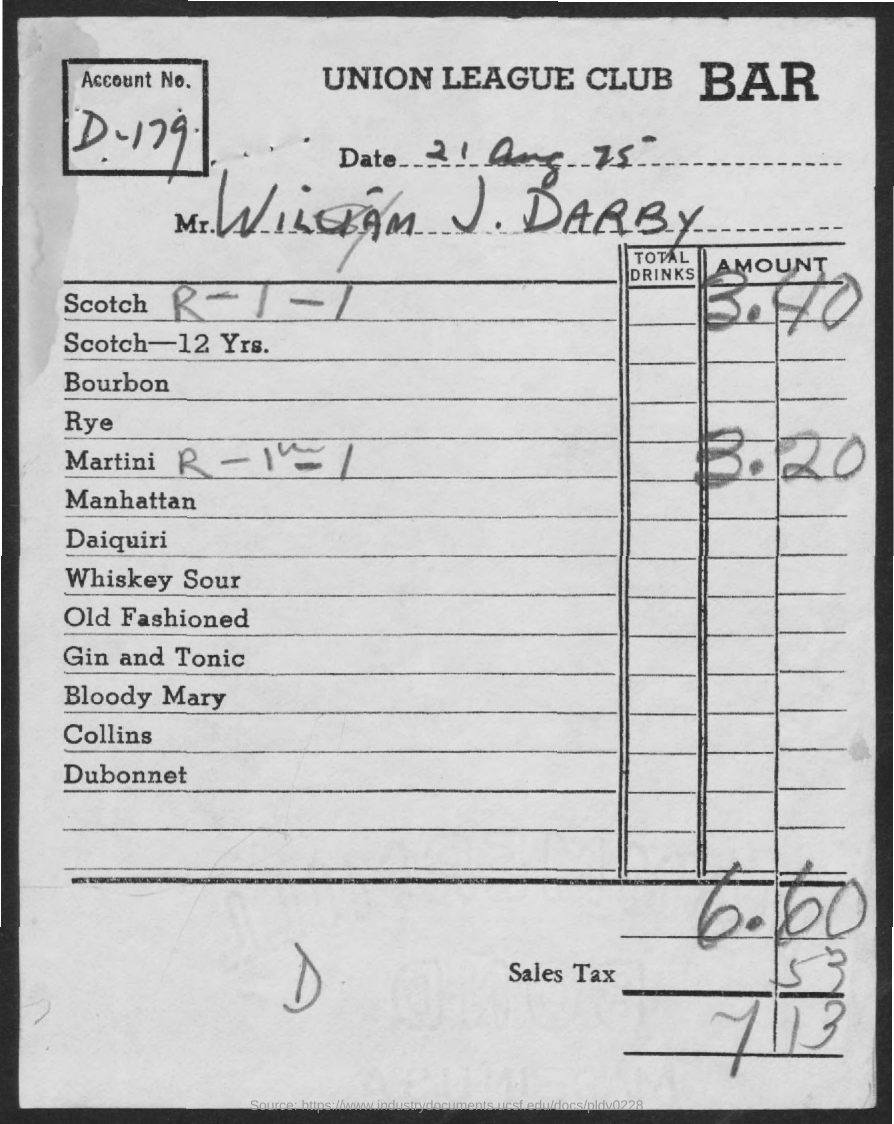Draw attention to some important aspects in this diagram. The amount for a Martini is 3.20. The amount for Scotch is 3.40. The account number is D-179. The document indicates that the date is 21 August 1975. The tax is 0.53. 